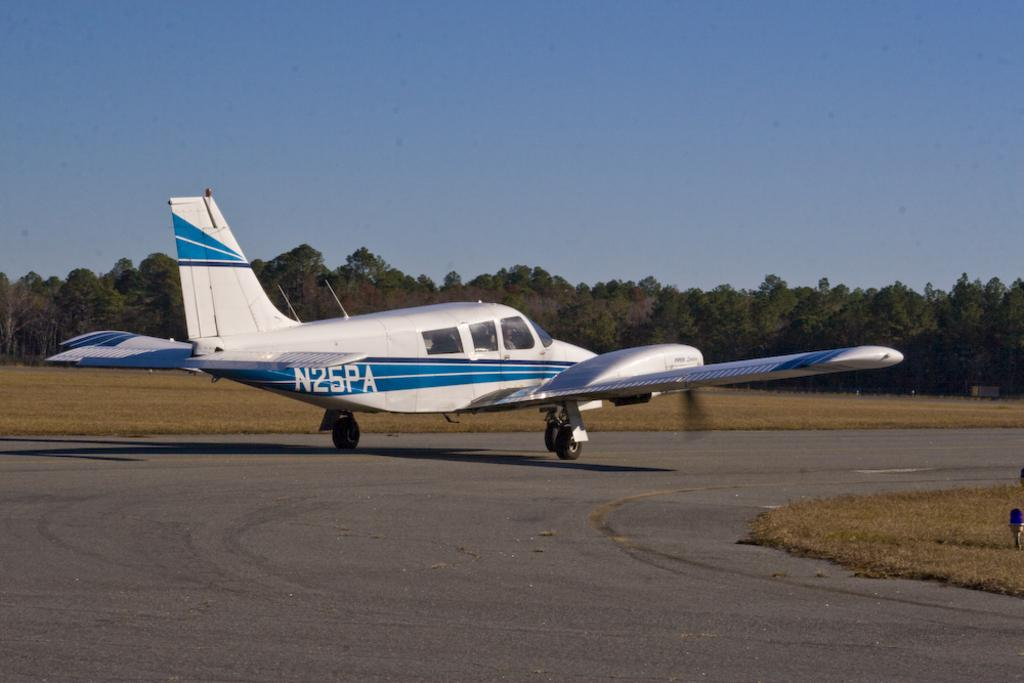<image>
Give a short and clear explanation of the subsequent image. the label N25PA is on the back of a plane 